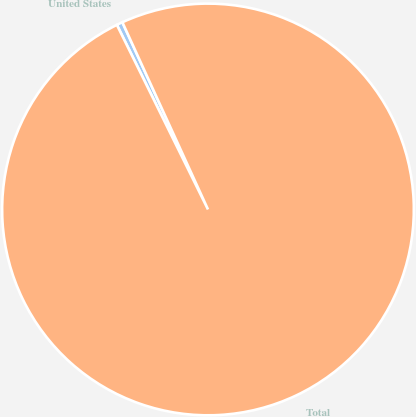<chart> <loc_0><loc_0><loc_500><loc_500><pie_chart><fcel>United States<fcel>Total<nl><fcel>0.47%<fcel>99.53%<nl></chart> 